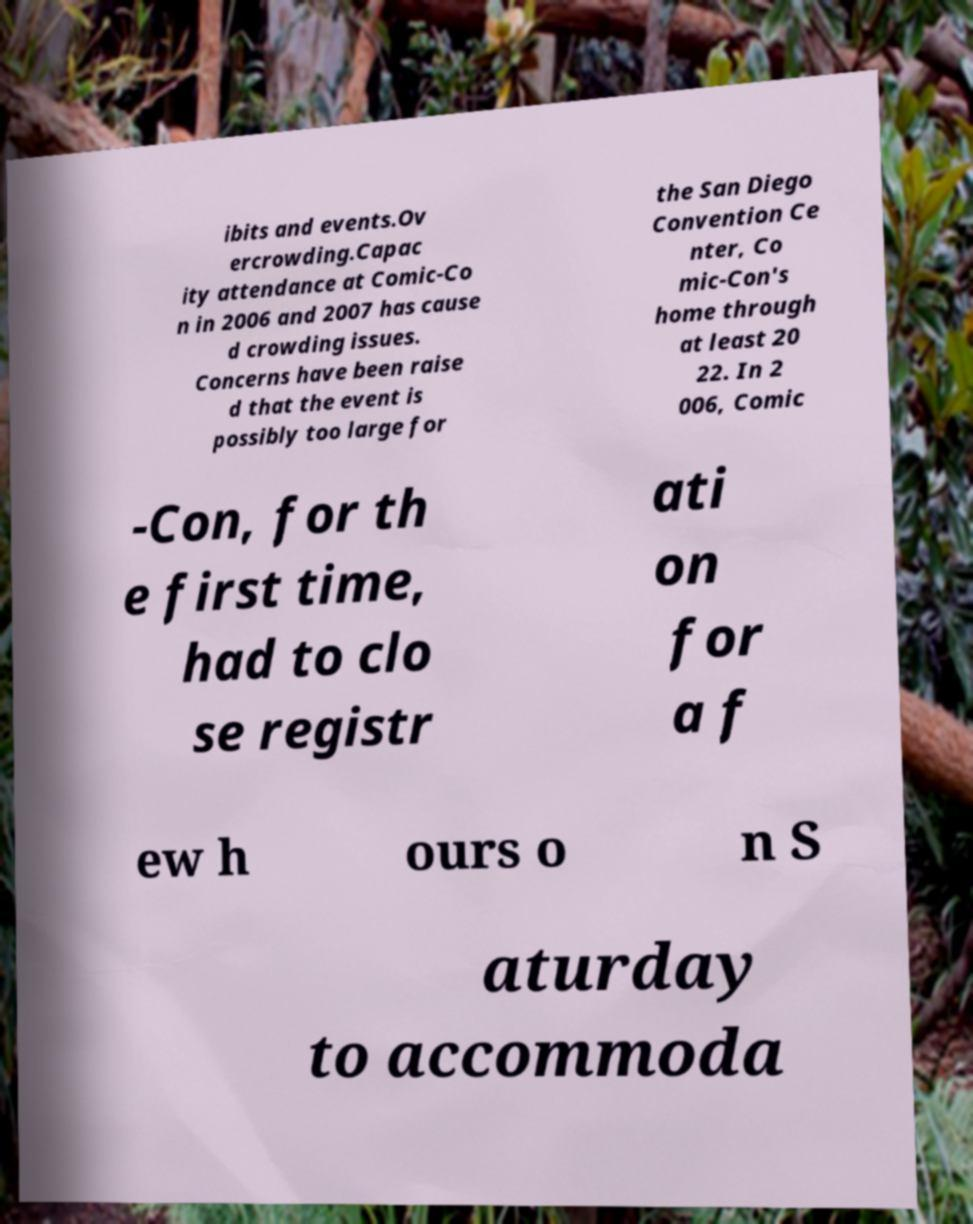I need the written content from this picture converted into text. Can you do that? ibits and events.Ov ercrowding.Capac ity attendance at Comic-Co n in 2006 and 2007 has cause d crowding issues. Concerns have been raise d that the event is possibly too large for the San Diego Convention Ce nter, Co mic-Con's home through at least 20 22. In 2 006, Comic -Con, for th e first time, had to clo se registr ati on for a f ew h ours o n S aturday to accommoda 